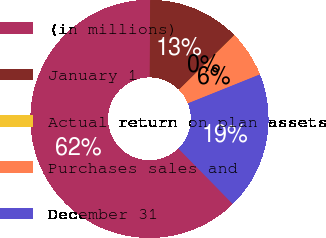<chart> <loc_0><loc_0><loc_500><loc_500><pie_chart><fcel>(in millions)<fcel>January 1<fcel>Actual return on plan assets<fcel>Purchases sales and<fcel>December 31<nl><fcel>62.43%<fcel>12.51%<fcel>0.03%<fcel>6.27%<fcel>18.75%<nl></chart> 